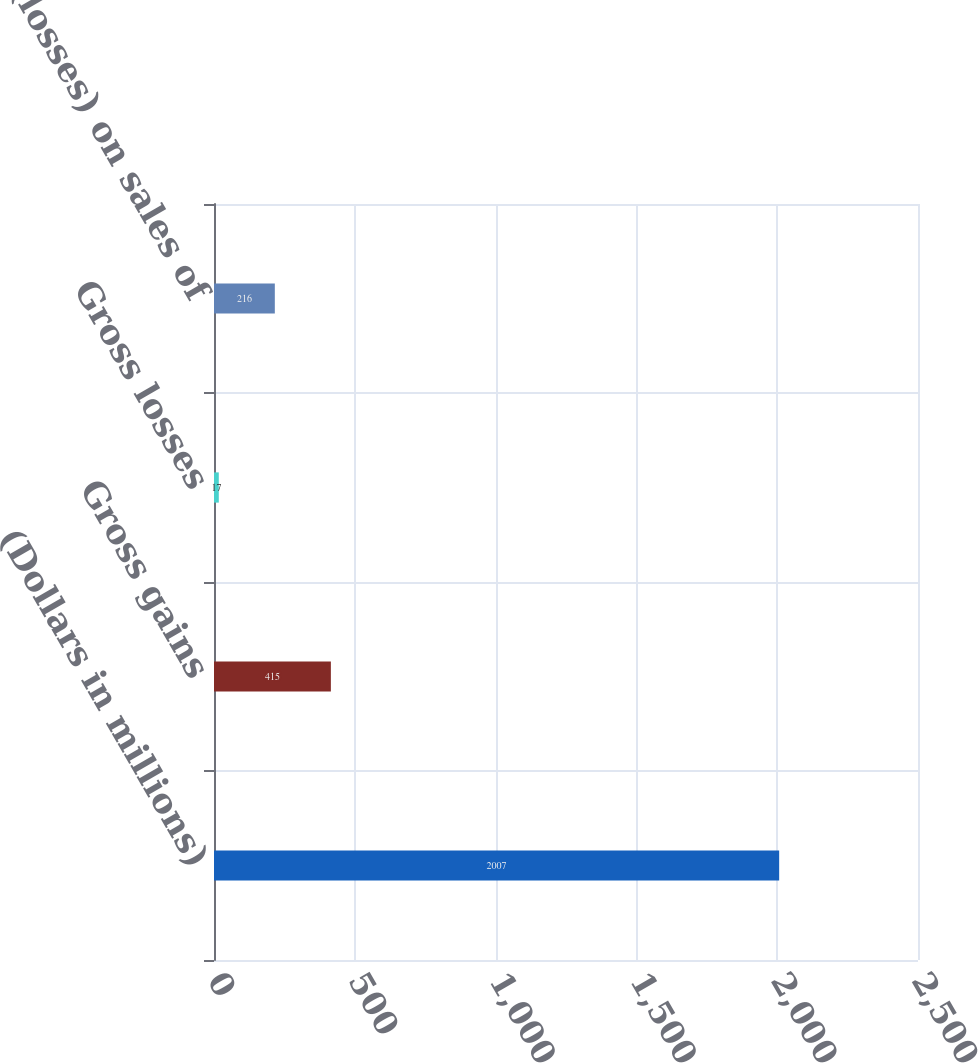Convert chart. <chart><loc_0><loc_0><loc_500><loc_500><bar_chart><fcel>(Dollars in millions)<fcel>Gross gains<fcel>Gross losses<fcel>Net gains (losses) on sales of<nl><fcel>2007<fcel>415<fcel>17<fcel>216<nl></chart> 